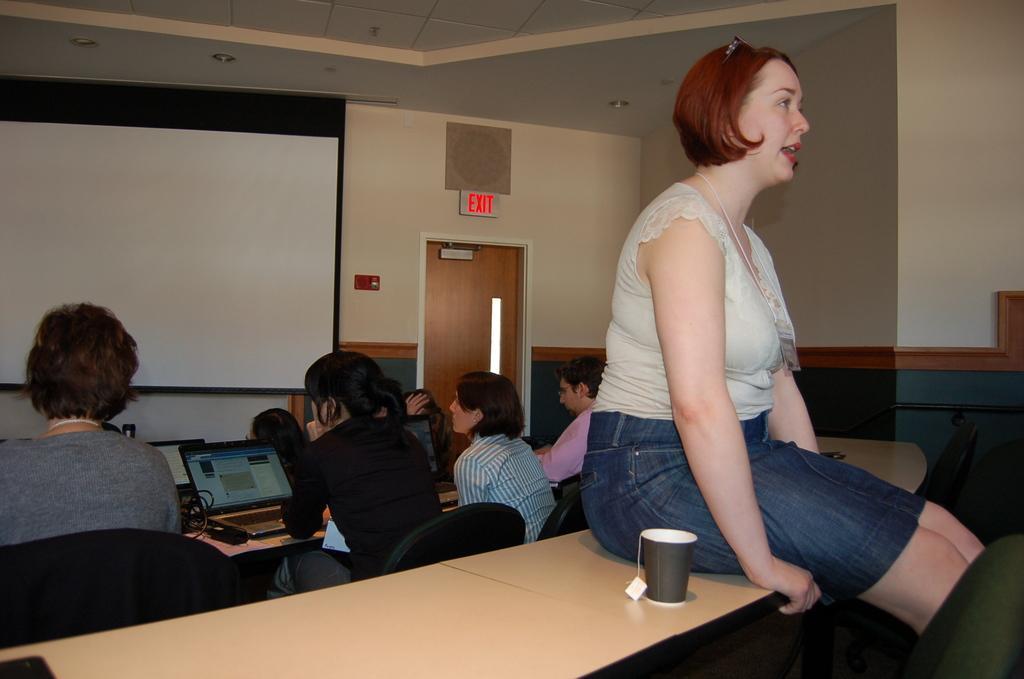Please provide a concise description of this image. A picture is taken inside the room. In the image there is a woman on right side who is sitting on bench. On bench we can see a glass,laptop,wires and there are group of people who are sitting on chairs. In background there is a board which is in white color and a door which is closed,wall and there is roof on top. 